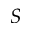Convert formula to latex. <formula><loc_0><loc_0><loc_500><loc_500>S</formula> 